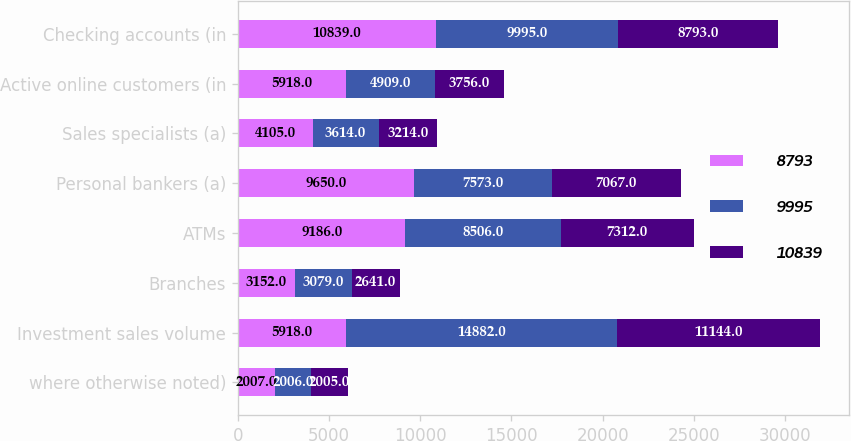Convert chart to OTSL. <chart><loc_0><loc_0><loc_500><loc_500><stacked_bar_chart><ecel><fcel>where otherwise noted)<fcel>Investment sales volume<fcel>Branches<fcel>ATMs<fcel>Personal bankers (a)<fcel>Sales specialists (a)<fcel>Active online customers (in<fcel>Checking accounts (in<nl><fcel>8793<fcel>2007<fcel>5918<fcel>3152<fcel>9186<fcel>9650<fcel>4105<fcel>5918<fcel>10839<nl><fcel>9995<fcel>2006<fcel>14882<fcel>3079<fcel>8506<fcel>7573<fcel>3614<fcel>4909<fcel>9995<nl><fcel>10839<fcel>2005<fcel>11144<fcel>2641<fcel>7312<fcel>7067<fcel>3214<fcel>3756<fcel>8793<nl></chart> 